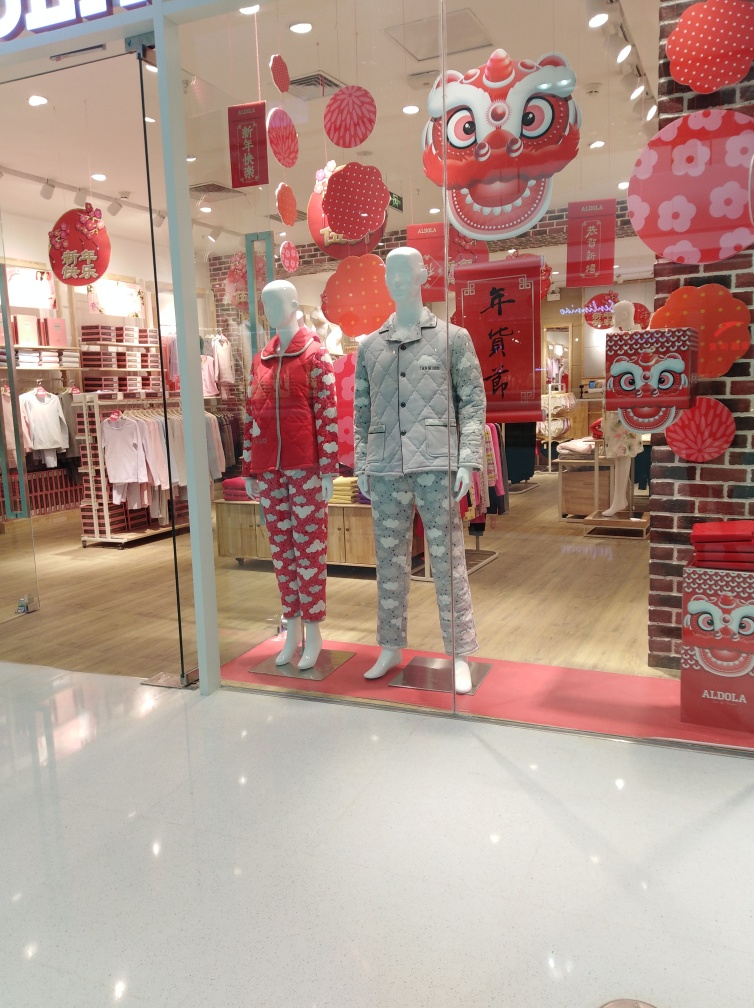Can you tell me more about the theme of the decorations? Absolutely, the decorations in the image are characteristic of Chinese New Year celebrations, featuring red lanterns, paper cuttings, and imagery of mythical creatures like dragons, which are auspicious symbols in Chinese culture. What do the different colors and patterns on the mannequins' clothing represent? The red attire with heart patterns on the female mannequin may symbolize love and joy, often associated with festive occasions, while the blue outfit on the male mannequin with snowflake motifs could represent the winter season. Together, they show a blend of traditional celebration themes with modern fashion trends. 